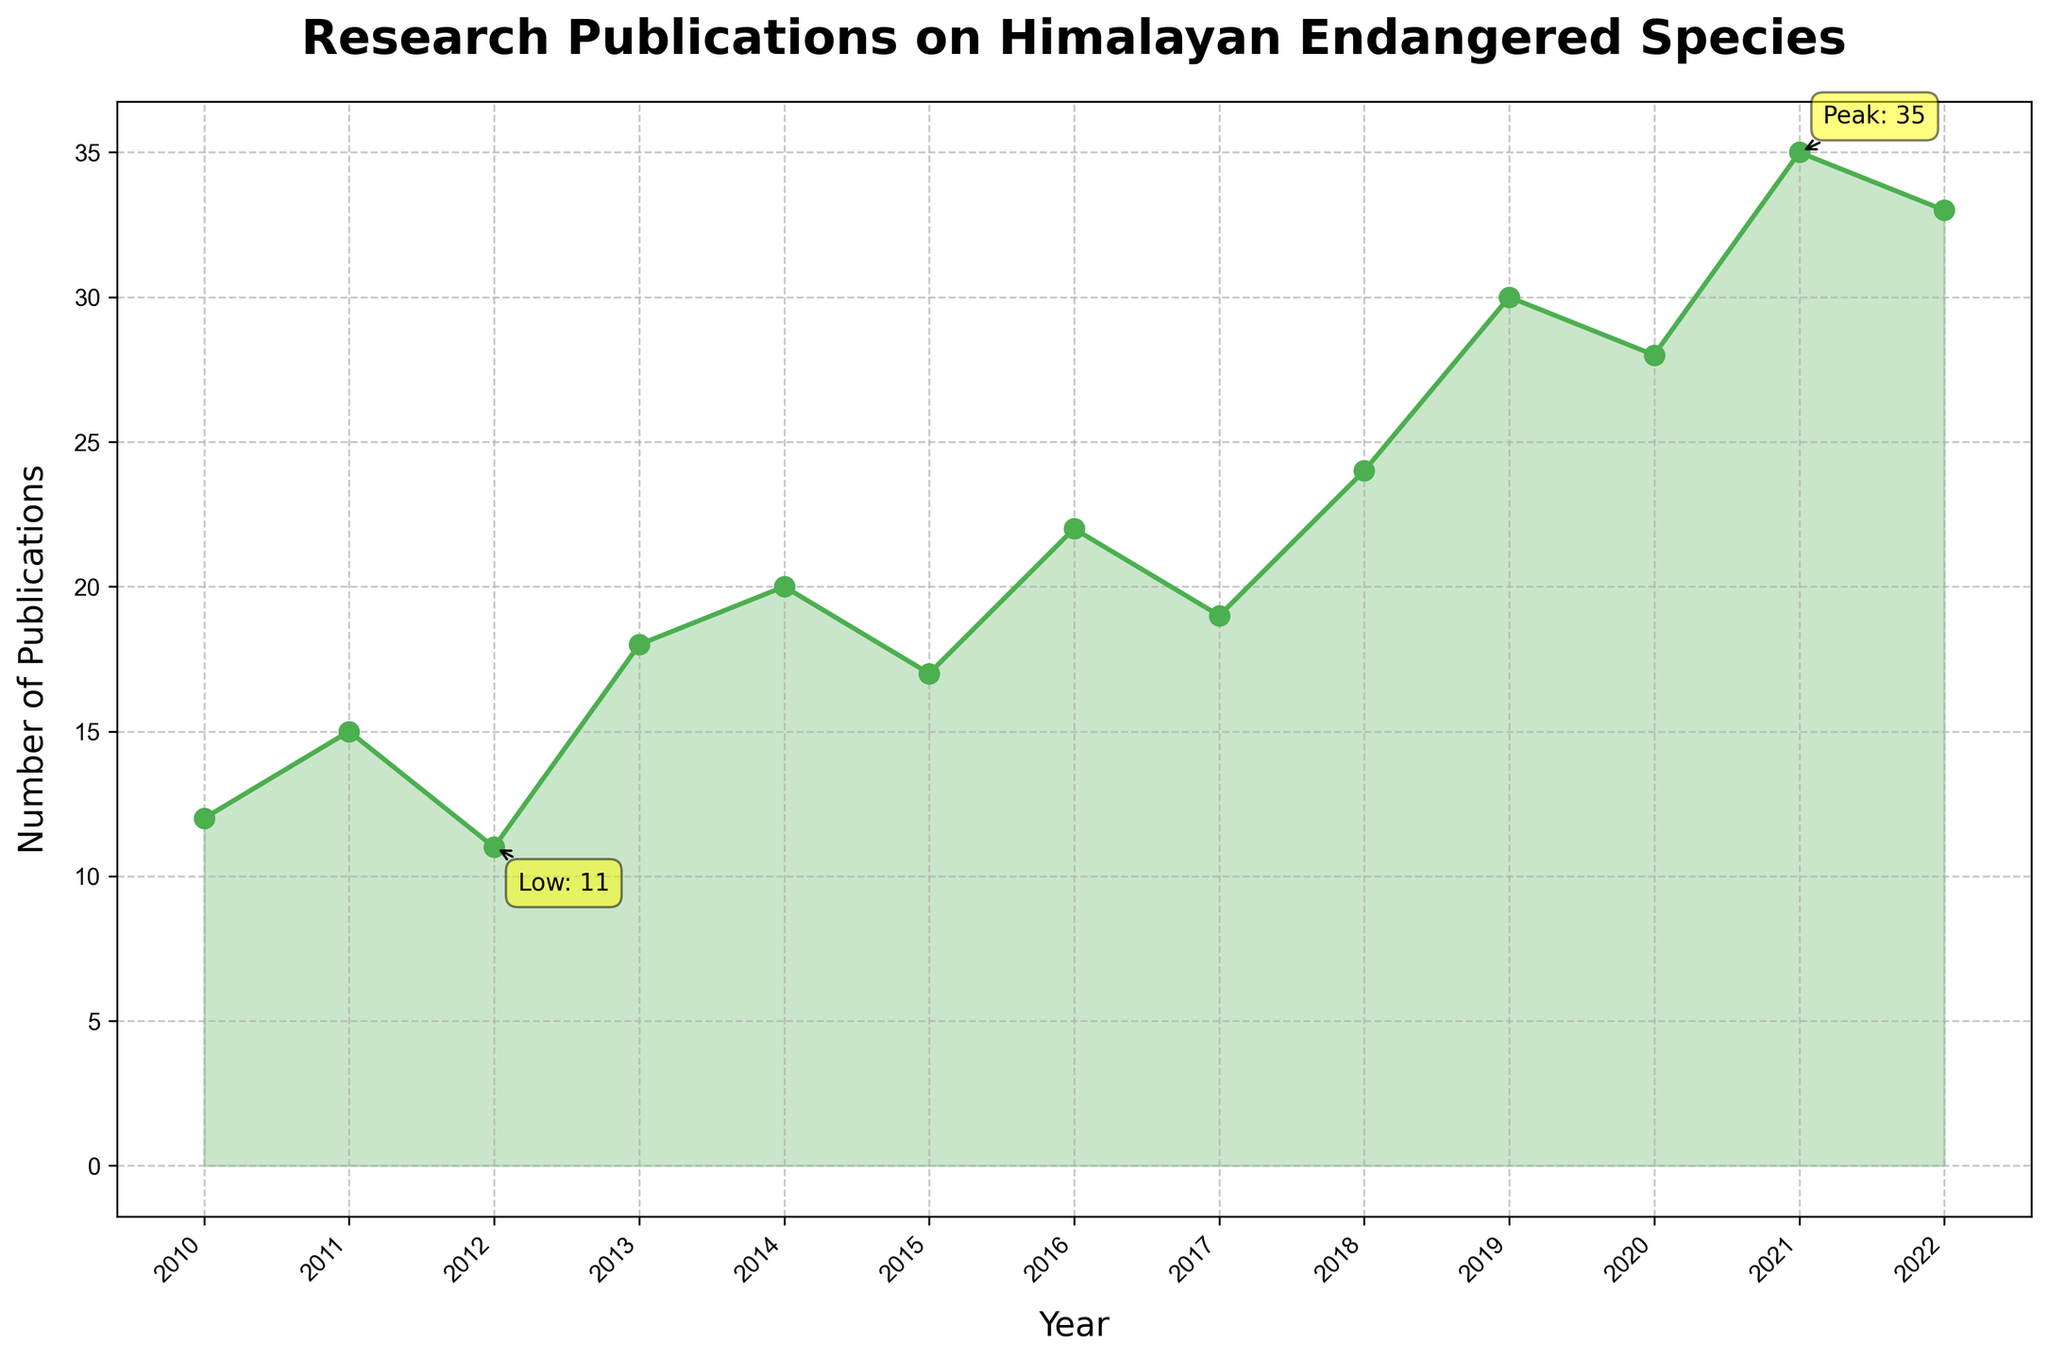What is the title of the plot? The title of the plot is located at the top of the figure and provides a summary of what the plot represents. By reading this text, we can determine that the title is "Research Publications on Himalayan Endangered Species."
Answer: Research Publications on Himalayan Endangered Species How many publications were there in 2013? Find the year 2013 on the x-axis, then look upwards to see the corresponding value on the y-axis, which represents the number of publications for that year. The value is 18.
Answer: 18 What was the peak number of publications, and in which year did it occur? The highest point on the y-axis indicates the peak number of publications. There is an annotation for the peak value directly on the plot. The peak number of publications is 35, and it occurred in 2021.
Answer: 35, 2021 Between which two consecutive years was the largest increase in the number of publications observed? To find the largest increase, look at the difference between consecutive years. The biggest jump is observed between 2018 (24 publications) and 2019 (30 publications), an increase of 6.
Answer: 2018 and 2019 What is the average number of publications per year over the given period? To calculate the average, sum all the publication values and divide by the number of years. The sum is 12+15+11+18+20+17+22+19+24+30+28+35+33 = 284. There are 13 years, so the average is 284/13 ≈ 21.85.
Answer: 21.85 How did the number of publications change from 2010 to 2022? Compare the values at the start (2010) and end (2022). In 2010, there were 12 publications, and by 2022, there were 33 publications, indicating an overall increase of 21 publications over the period.
Answer: Increased by 21 Which year had the lowest number of publications? Locate the lowest point on the plot visually or by annotation. The lowest number of publications is 11, which occurred in 2012.
Answer: 2012 By how much did the number of publications increase from 2010 to 2014? Find the values for 2010 (12 publications) and 2014 (20 publications). Subtract the 2010 value from the 2014 value: 20 - 12 = 8.
Answer: 8 What trend can be observed in the number of publications from 2017 to 2021? Observe the plot from 2017 to 2021. The number of publications increases each year: 2017 (19), 2018 (24), 2019 (30), 2020 (28), 2021 (35). This shows an overall increasing trend.
Answer: Increasing trend Is there any year where the number of publications decreased from the previous year? If so, which year? Identify any downward slope in the plot. The number of publications decreased from 2019 (30) to 2020 (28), which is a drop.
Answer: 2020 